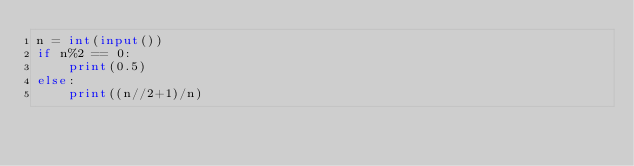<code> <loc_0><loc_0><loc_500><loc_500><_Python_>n = int(input())
if n%2 == 0:
    print(0.5)
else:
    print((n//2+1)/n)</code> 